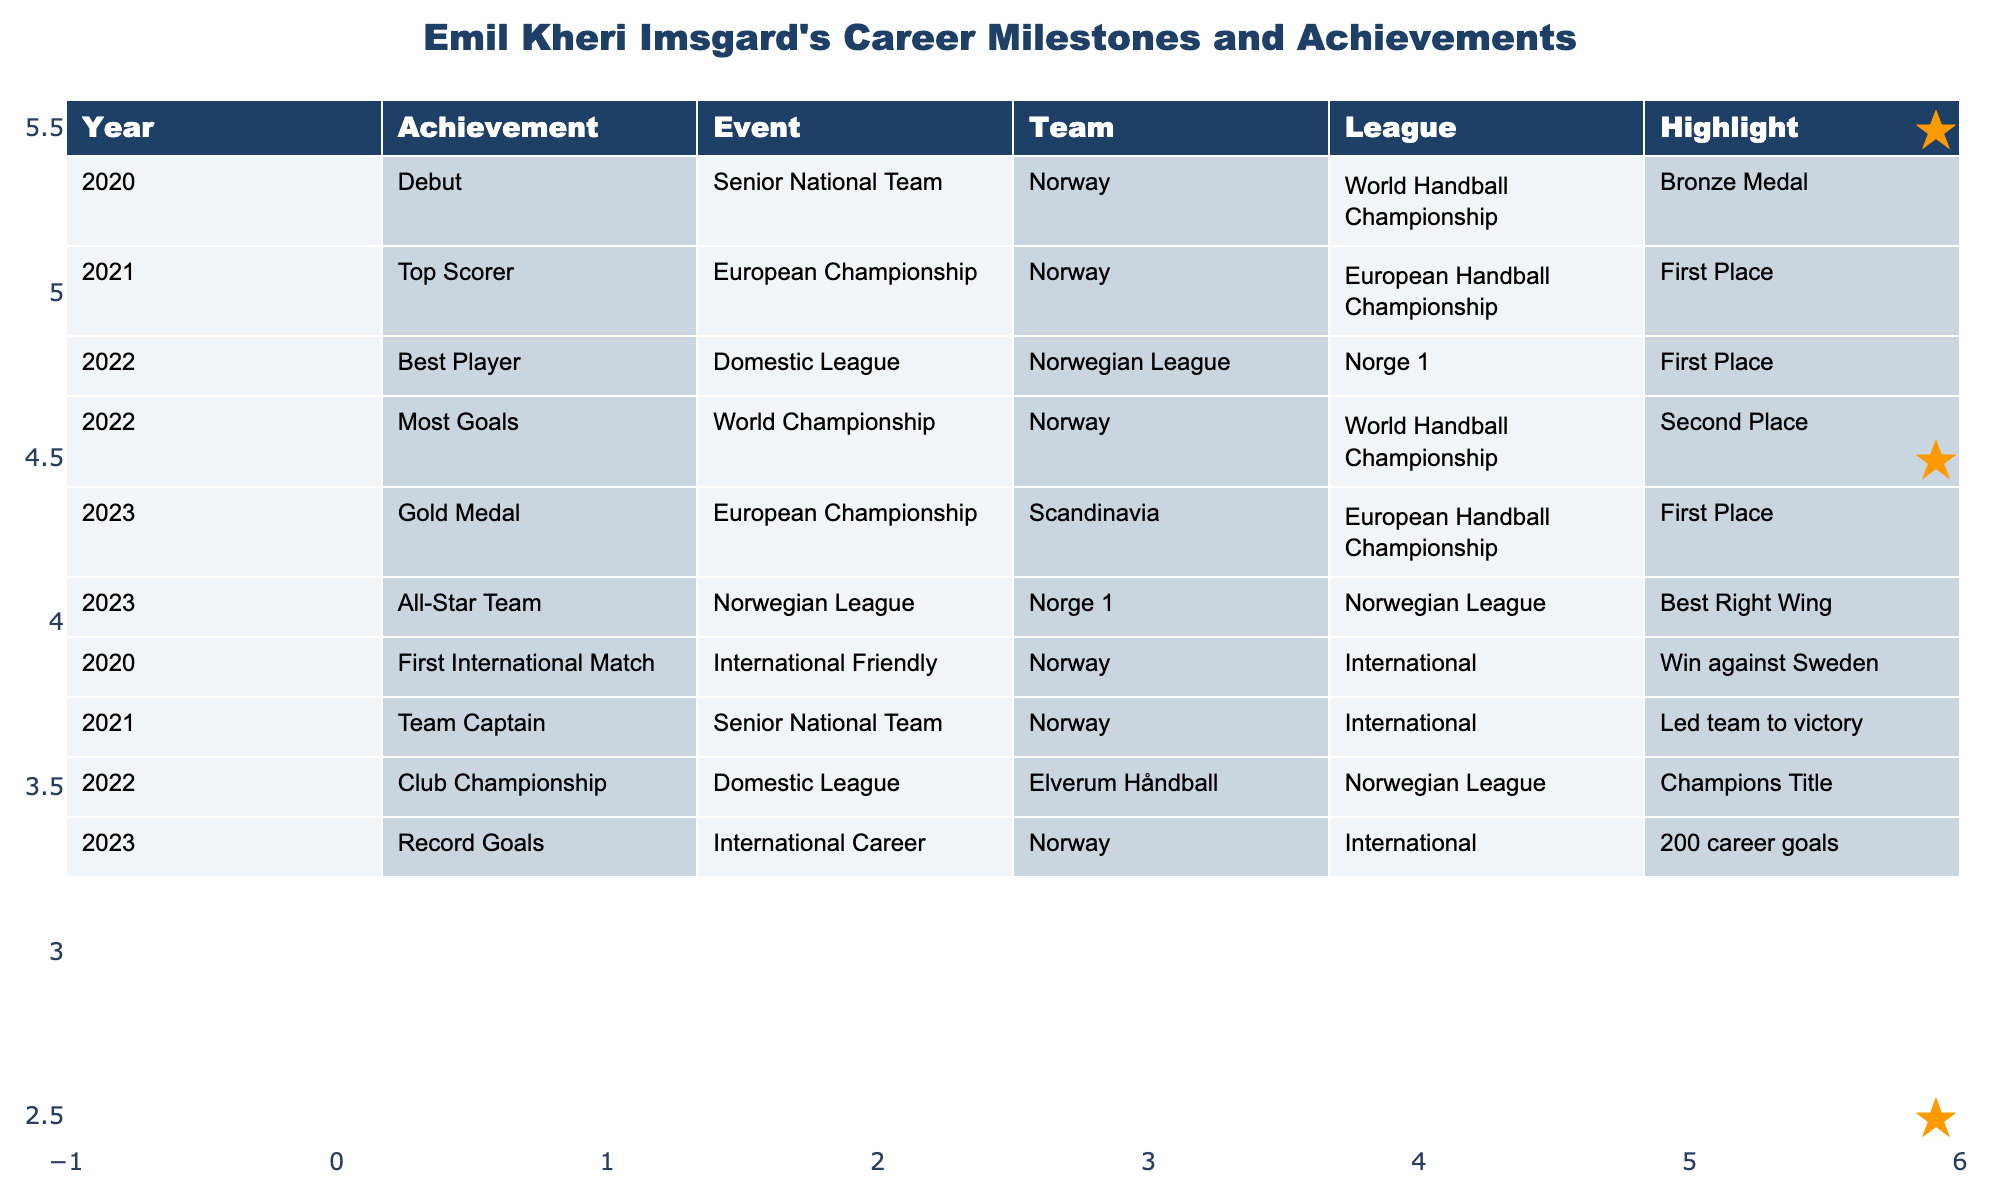What achievement did Emil Kheri Imsgard receive in 2021? In 2021, he was the Top Scorer at the European Championship.
Answer: Top Scorer How many Gold Medals has Emil Kheri Imsgard won in total? He won one Gold Medal at the European Championship in 2023.
Answer: 1 Did Emil Kheri Imsgard serve as captain for the Norwegian National Team? Yes, he was Team Captain in 2021.
Answer: Yes What was Emil Kheri Imsgard's total number of career goals by 2023? By 2023, he achieved 200 career goals.
Answer: 200 What year did Emil Kheri Imsgard debut with the Senior National Team? He made his debut in the year 2020.
Answer: 2020 Which achievement has Emil Kheri Imsgard the highest ranking in according to the table? The achievements marked with a star indicate he was Best Player and part of the All-Star Team, along with the Gold Medal. The highest ranking is subjective, but all were significant.
Answer: Gold Medal, Best Player, All-Star Team In which league did Emil Kheri Imsgard achieve the Best Player award? He achieved the Best Player award in the Norwegian League.
Answer: Norwegian League How many times has Emil Kheri Imsgard been part of an All-Star Team? He was part of the All-Star Team in 2023.
Answer: 1 time Which event did Emil Kheri Imsgard highlight in 2022 besides his Best Player recognition? In 2022, he also ranked as Most Goals at the World Championship.
Answer: Most Goals In what year did Emil Kheri Imsgard help Norway win a bronze medal? He helped Norway win a bronze medal in 2020 at the World Handball Championship.
Answer: 2020 What events did Emil Kheri Imsgard participate in during 2023? He participated in the European Championship, where he won a Gold Medal, and was also named to the All-Star Team in the Norwegian League.
Answer: European Championship and Norwegian League 